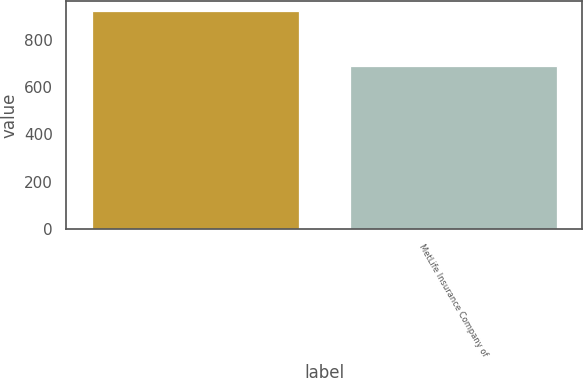<chart> <loc_0><loc_0><loc_500><loc_500><bar_chart><ecel><fcel>MetLife Insurance Company of<nl><fcel>919<fcel>690<nl></chart> 